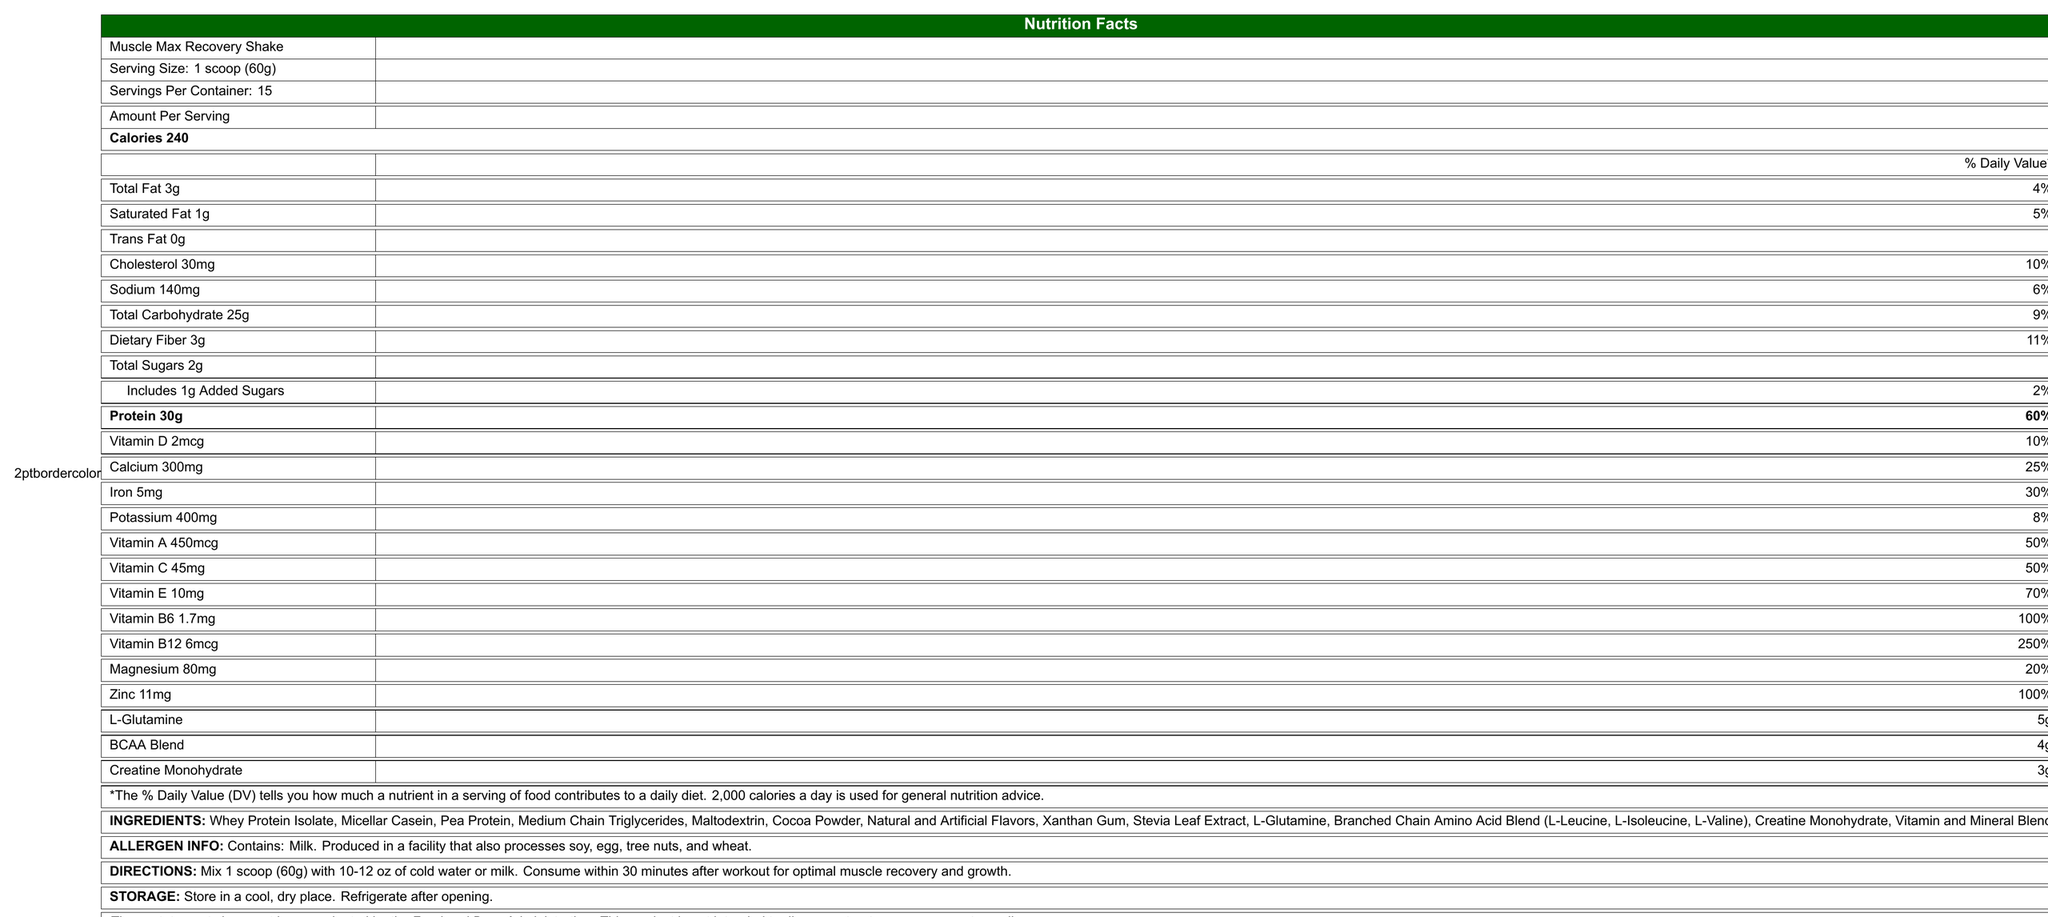how many grams of protein are in one serving? The nutritional facts state that there are 30g of protein per serving.
Answer: 30g how many calories are in one scoop? The document specifies that each serving contains 240 calories.
Answer: 240 what percentage of daily value is the vitamin B12 in one serving? The document mentions that a single serving provides 250% of the daily value for vitamin B12.
Answer: 250% what is the serving size for this product? The serving size is clearly indicated as "1 scoop (60g)".
Answer: 1 scoop (60g) how many servings are in the container? The label clearly states that there are 15 servings per container.
Answer: 15 how much dietary fiber does one serving provide? A. 4g B. 2g C. 3g The nutrition facts label states that each serving provides 3g of dietary fiber.
Answer: C. 3g what are the ingredients used in this product? A. Whey Protein Isolate, Micellar Casein, Pea Protein B. Medium Chain Triglycerides, Cocoa Powder, Natural and Artificial Flavors C. Xanthan Gum, Stevia Leaf Extract, L-Glutamine D. All of the above The ingredients list includes all options: Whey Protein Isolate, Micellar Casein, Pea Protein, Medium Chain Triglycerides, Cocoa Powder, Natural and Artificial Flavors, Xanthan Gum, Stevia Leaf Extract, L-Glutamine, etc.
Answer: D. All of the above does this product contain any allergens? Yes/No The allergen information states that the product contains milk and is produced in a facility that processes soy, egg, tree nuts, and wheat.
Answer: Yes summarize the main nutritional benefits of Muscle Max Recovery Shake. The document highlights that each serving contains high protein content, essential vitamins and minerals, low added sugars, and additional supplements beneficial for muscle recovery and growth.
Answer: Muscle Max Recovery Shake provides 30g of protein, 240 calories, essential vitamins and minerals like vitamin B12, vitamin C, calcium, and iron, and added performance enhancers like L-Glutamine, BCAA blend, and creatine monohydrate. does this product have any gluten? The document states that the product is produced in a facility that processes wheat, but it doesn't specify if the product itself contains gluten.
Answer: Cannot be determined what is the function of L-Glutamine in the product? The document lists L-Glutamine as an ingredient but does not explain its function.
Answer: I don't know 